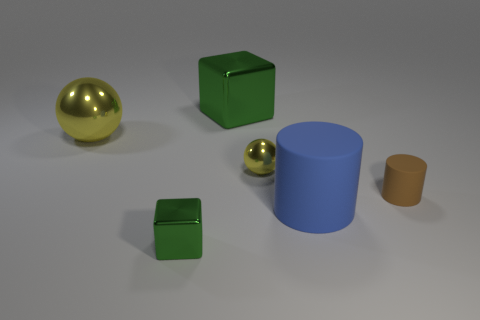Add 2 big gray matte spheres. How many objects exist? 8 Subtract all blocks. How many objects are left? 4 Subtract 0 cyan cubes. How many objects are left? 6 Subtract all small yellow things. Subtract all small brown cylinders. How many objects are left? 4 Add 2 small blocks. How many small blocks are left? 3 Add 4 tiny things. How many tiny things exist? 7 